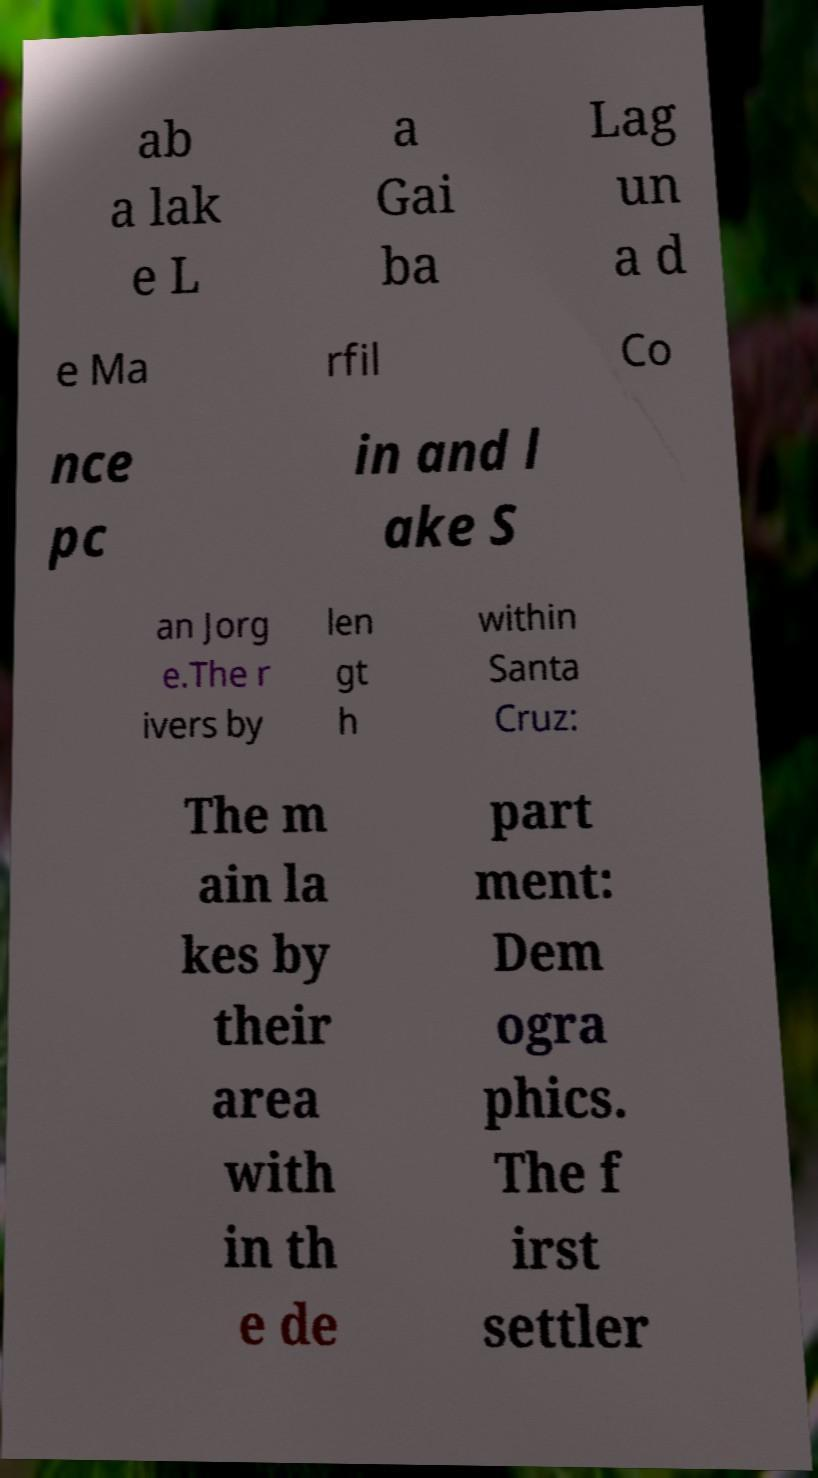I need the written content from this picture converted into text. Can you do that? ab a lak e L a Gai ba Lag un a d e Ma rfil Co nce pc in and l ake S an Jorg e.The r ivers by len gt h within Santa Cruz: The m ain la kes by their area with in th e de part ment: Dem ogra phics. The f irst settler 